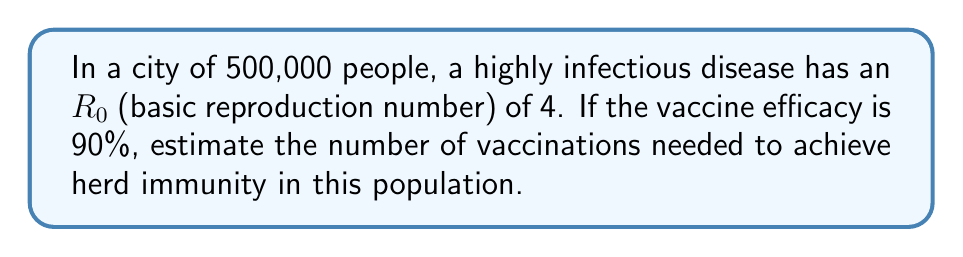Show me your answer to this math problem. Let's approach this step-by-step:

1) The formula for herd immunity threshold is:

   $$H = 1 - \frac{1}{R_0}$$

   Where $H$ is the herd immunity threshold and $R_0$ is the basic reproduction number.

2) Given $R_0 = 4$, we can calculate $H$:

   $$H = 1 - \frac{1}{4} = 0.75$$

   This means 75% of the population needs to be immune to achieve herd immunity.

3) However, the vaccine is not 100% effective. We need to account for vaccine efficacy:

   $$\text{Proportion to vaccinate} = \frac{H}{\text{Vaccine Efficacy}}$$

4) With 90% vaccine efficacy:

   $$\text{Proportion to vaccinate} = \frac{0.75}{0.90} \approx 0.833$$

5) To find the number of people to vaccinate in a population of 500,000:

   $$\text{Number to vaccinate} = 500,000 \times 0.833 \approx 416,500$$

Therefore, approximately 416,500 vaccinations are needed to achieve herd immunity in this population.
Answer: 416,500 vaccinations 